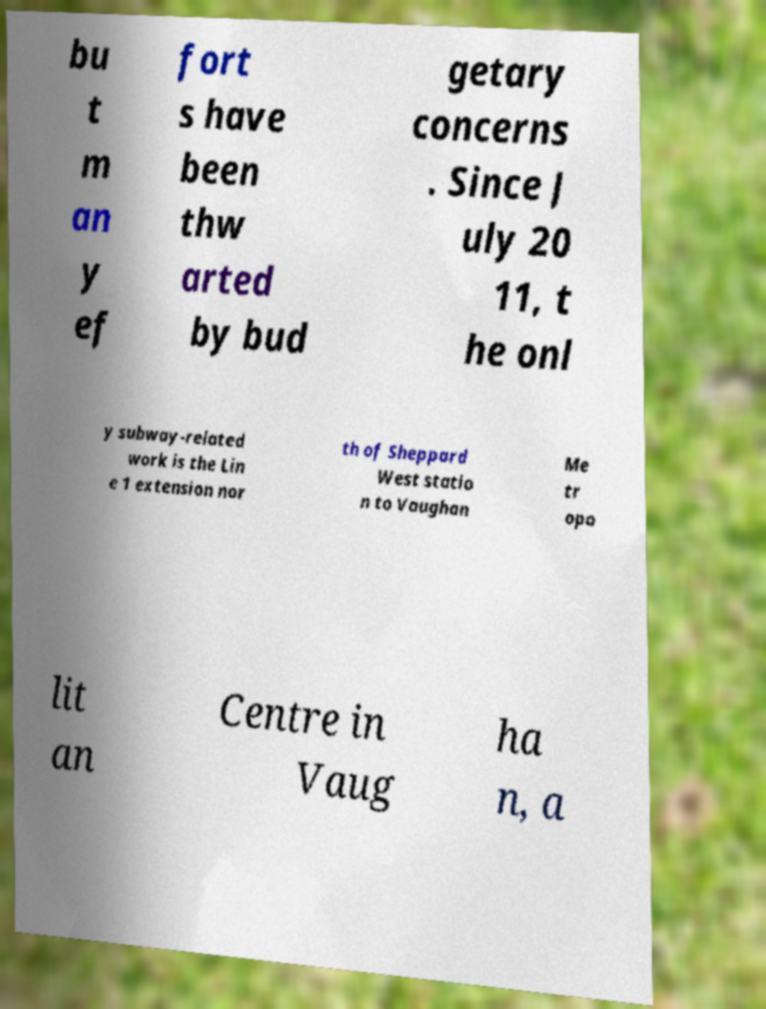Please read and relay the text visible in this image. What does it say? bu t m an y ef fort s have been thw arted by bud getary concerns . Since J uly 20 11, t he onl y subway-related work is the Lin e 1 extension nor th of Sheppard West statio n to Vaughan Me tr opo lit an Centre in Vaug ha n, a 